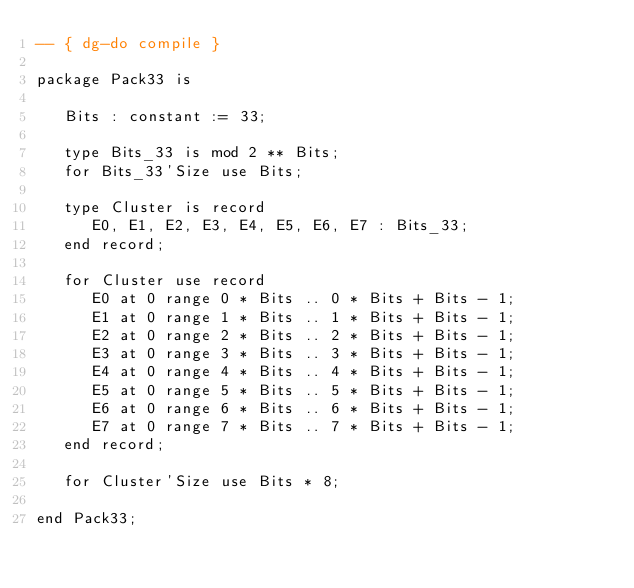Convert code to text. <code><loc_0><loc_0><loc_500><loc_500><_Ada_>-- { dg-do compile }

package Pack33 is

   Bits : constant := 33;

   type Bits_33 is mod 2 ** Bits;
   for Bits_33'Size use Bits;

   type Cluster is record
      E0, E1, E2, E3, E4, E5, E6, E7 : Bits_33;
   end record;

   for Cluster use record
      E0 at 0 range 0 * Bits .. 0 * Bits + Bits - 1;
      E1 at 0 range 1 * Bits .. 1 * Bits + Bits - 1;
      E2 at 0 range 2 * Bits .. 2 * Bits + Bits - 1;
      E3 at 0 range 3 * Bits .. 3 * Bits + Bits - 1;
      E4 at 0 range 4 * Bits .. 4 * Bits + Bits - 1;
      E5 at 0 range 5 * Bits .. 5 * Bits + Bits - 1;
      E6 at 0 range 6 * Bits .. 6 * Bits + Bits - 1;
      E7 at 0 range 7 * Bits .. 7 * Bits + Bits - 1;
   end record;

   for Cluster'Size use Bits * 8;

end Pack33;
</code> 